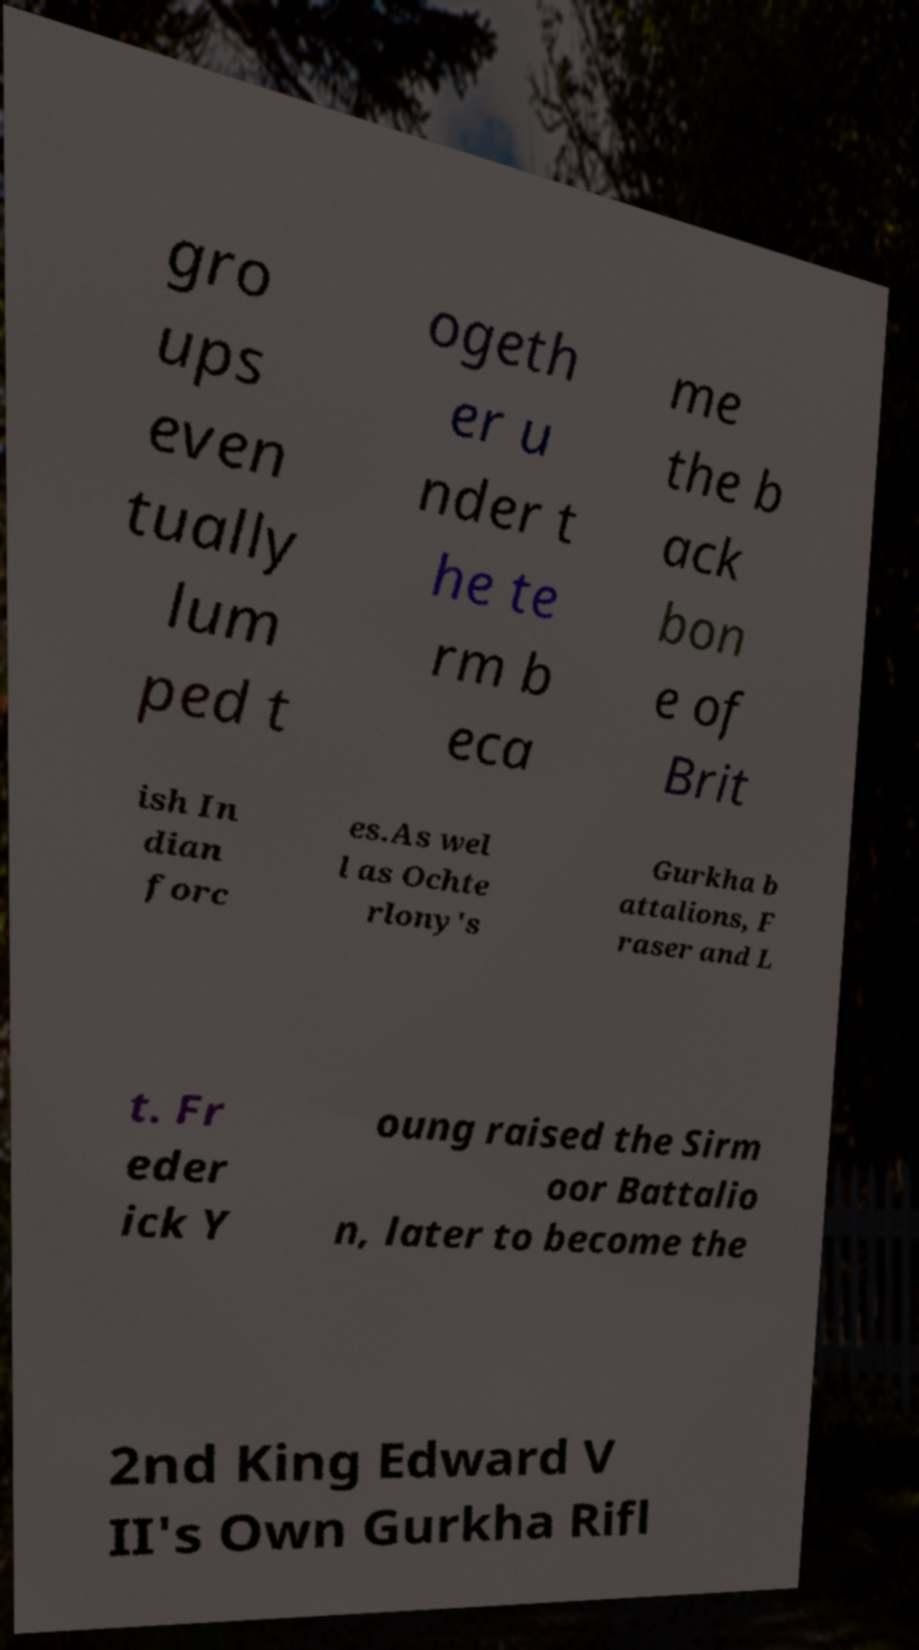What messages or text are displayed in this image? I need them in a readable, typed format. gro ups even tually lum ped t ogeth er u nder t he te rm b eca me the b ack bon e of Brit ish In dian forc es.As wel l as Ochte rlony's Gurkha b attalions, F raser and L t. Fr eder ick Y oung raised the Sirm oor Battalio n, later to become the 2nd King Edward V II's Own Gurkha Rifl 